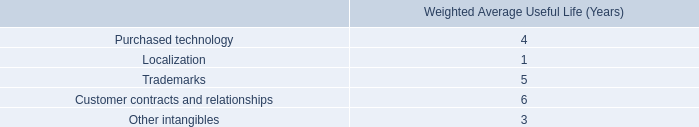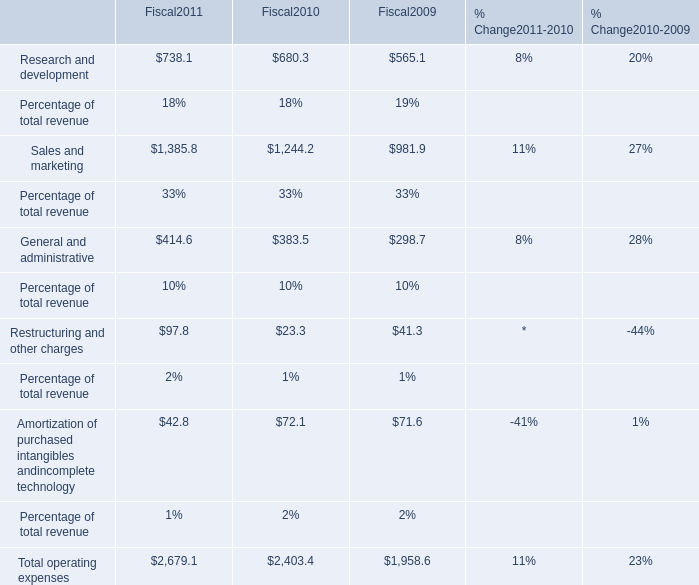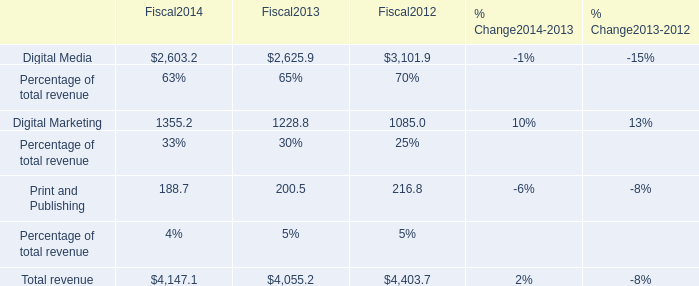What's the growth rate of Research and development in 2011? 
Computations: ((738.1 - 680.3) / 680.3)
Answer: 0.08496. 